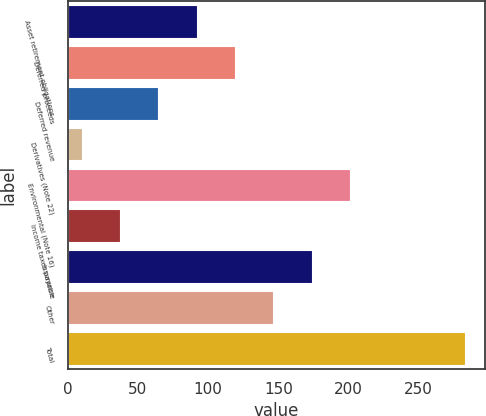Convert chart to OTSL. <chart><loc_0><loc_0><loc_500><loc_500><bar_chart><fcel>Asset retirement obligations<fcel>Deferred proceeds<fcel>Deferred revenue<fcel>Derivatives (Note 22)<fcel>Environmental (Note 16)<fcel>Income taxes payable<fcel>Insurance<fcel>Other<fcel>Total<nl><fcel>91.9<fcel>119.2<fcel>64.6<fcel>10<fcel>201.1<fcel>37.3<fcel>173.8<fcel>146.5<fcel>283<nl></chart> 